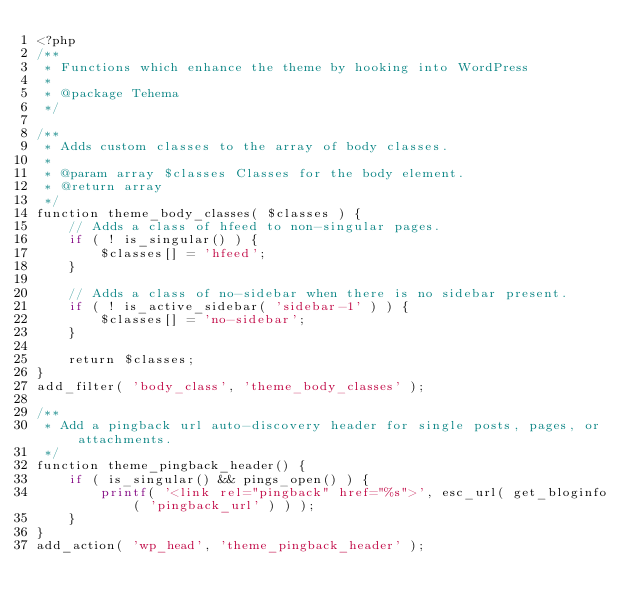Convert code to text. <code><loc_0><loc_0><loc_500><loc_500><_PHP_><?php
/**
 * Functions which enhance the theme by hooking into WordPress
 *
 * @package Tehema
 */

/**
 * Adds custom classes to the array of body classes.
 *
 * @param array $classes Classes for the body element.
 * @return array
 */
function theme_body_classes( $classes ) {
	// Adds a class of hfeed to non-singular pages.
	if ( ! is_singular() ) {
		$classes[] = 'hfeed';
	}

	// Adds a class of no-sidebar when there is no sidebar present.
	if ( ! is_active_sidebar( 'sidebar-1' ) ) {
		$classes[] = 'no-sidebar';
	}

	return $classes;
}
add_filter( 'body_class', 'theme_body_classes' );

/**
 * Add a pingback url auto-discovery header for single posts, pages, or attachments.
 */
function theme_pingback_header() {
	if ( is_singular() && pings_open() ) {
		printf( '<link rel="pingback" href="%s">', esc_url( get_bloginfo( 'pingback_url' ) ) );
	}
}
add_action( 'wp_head', 'theme_pingback_header' );
</code> 